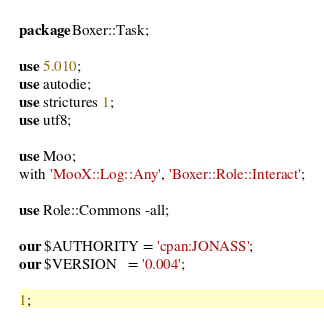<code> <loc_0><loc_0><loc_500><loc_500><_Perl_>package Boxer::Task;

use 5.010;
use autodie;
use strictures 1;
use utf8;

use Moo;
with 'MooX::Log::Any', 'Boxer::Role::Interact';

use Role::Commons -all;

our $AUTHORITY = 'cpan:JONASS';
our $VERSION   = '0.004';

1;
</code> 